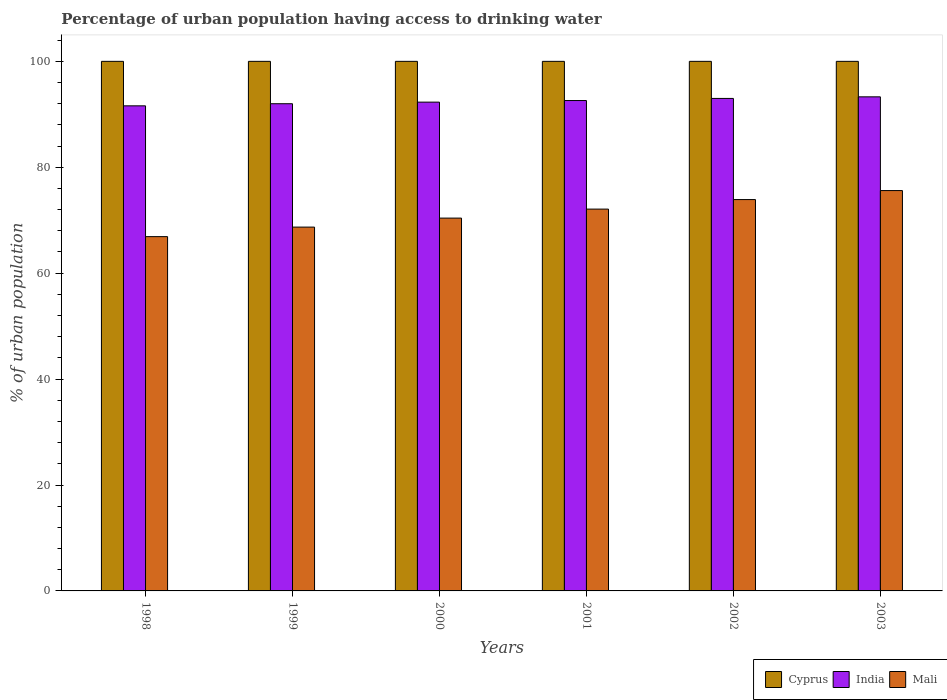How many groups of bars are there?
Provide a short and direct response. 6. Are the number of bars per tick equal to the number of legend labels?
Your response must be concise. Yes. What is the label of the 3rd group of bars from the left?
Your answer should be compact. 2000. In how many cases, is the number of bars for a given year not equal to the number of legend labels?
Provide a short and direct response. 0. What is the percentage of urban population having access to drinking water in Mali in 1999?
Provide a succinct answer. 68.7. Across all years, what is the maximum percentage of urban population having access to drinking water in India?
Offer a very short reply. 93.3. Across all years, what is the minimum percentage of urban population having access to drinking water in Mali?
Provide a succinct answer. 66.9. What is the total percentage of urban population having access to drinking water in Cyprus in the graph?
Ensure brevity in your answer.  600. What is the difference between the percentage of urban population having access to drinking water in India in 2000 and that in 2001?
Give a very brief answer. -0.3. What is the difference between the percentage of urban population having access to drinking water in Mali in 2002 and the percentage of urban population having access to drinking water in India in 1999?
Your response must be concise. -18.1. What is the average percentage of urban population having access to drinking water in Cyprus per year?
Provide a short and direct response. 100. In the year 1998, what is the difference between the percentage of urban population having access to drinking water in Mali and percentage of urban population having access to drinking water in Cyprus?
Provide a short and direct response. -33.1. In how many years, is the percentage of urban population having access to drinking water in India greater than 80 %?
Your answer should be compact. 6. What is the ratio of the percentage of urban population having access to drinking water in Mali in 1998 to that in 2000?
Offer a terse response. 0.95. Is the percentage of urban population having access to drinking water in Mali in 2000 less than that in 2002?
Provide a succinct answer. Yes. What is the difference between the highest and the second highest percentage of urban population having access to drinking water in Cyprus?
Your answer should be very brief. 0. What is the difference between the highest and the lowest percentage of urban population having access to drinking water in India?
Provide a short and direct response. 1.7. What does the 1st bar from the left in 2003 represents?
Give a very brief answer. Cyprus. What does the 1st bar from the right in 2001 represents?
Offer a very short reply. Mali. Is it the case that in every year, the sum of the percentage of urban population having access to drinking water in India and percentage of urban population having access to drinking water in Mali is greater than the percentage of urban population having access to drinking water in Cyprus?
Ensure brevity in your answer.  Yes. How many bars are there?
Make the answer very short. 18. How many years are there in the graph?
Offer a very short reply. 6. Are the values on the major ticks of Y-axis written in scientific E-notation?
Your answer should be compact. No. What is the title of the graph?
Make the answer very short. Percentage of urban population having access to drinking water. What is the label or title of the X-axis?
Provide a short and direct response. Years. What is the label or title of the Y-axis?
Your answer should be very brief. % of urban population. What is the % of urban population of Cyprus in 1998?
Make the answer very short. 100. What is the % of urban population in India in 1998?
Your answer should be very brief. 91.6. What is the % of urban population of Mali in 1998?
Make the answer very short. 66.9. What is the % of urban population of India in 1999?
Provide a short and direct response. 92. What is the % of urban population in Mali in 1999?
Keep it short and to the point. 68.7. What is the % of urban population of India in 2000?
Your answer should be compact. 92.3. What is the % of urban population in Mali in 2000?
Provide a short and direct response. 70.4. What is the % of urban population in Cyprus in 2001?
Your answer should be very brief. 100. What is the % of urban population in India in 2001?
Give a very brief answer. 92.6. What is the % of urban population of Mali in 2001?
Your answer should be very brief. 72.1. What is the % of urban population in India in 2002?
Your answer should be compact. 93. What is the % of urban population in Mali in 2002?
Provide a short and direct response. 73.9. What is the % of urban population of India in 2003?
Provide a short and direct response. 93.3. What is the % of urban population in Mali in 2003?
Your response must be concise. 75.6. Across all years, what is the maximum % of urban population of Cyprus?
Give a very brief answer. 100. Across all years, what is the maximum % of urban population of India?
Make the answer very short. 93.3. Across all years, what is the maximum % of urban population of Mali?
Offer a very short reply. 75.6. Across all years, what is the minimum % of urban population in India?
Give a very brief answer. 91.6. Across all years, what is the minimum % of urban population of Mali?
Make the answer very short. 66.9. What is the total % of urban population in Cyprus in the graph?
Your response must be concise. 600. What is the total % of urban population of India in the graph?
Your response must be concise. 554.8. What is the total % of urban population of Mali in the graph?
Your response must be concise. 427.6. What is the difference between the % of urban population of Cyprus in 1998 and that in 1999?
Provide a short and direct response. 0. What is the difference between the % of urban population of Mali in 1998 and that in 1999?
Your response must be concise. -1.8. What is the difference between the % of urban population of Cyprus in 1998 and that in 2000?
Your response must be concise. 0. What is the difference between the % of urban population of India in 1998 and that in 2000?
Your answer should be very brief. -0.7. What is the difference between the % of urban population of Mali in 1998 and that in 2000?
Your answer should be very brief. -3.5. What is the difference between the % of urban population in Cyprus in 1998 and that in 2002?
Ensure brevity in your answer.  0. What is the difference between the % of urban population of Mali in 1999 and that in 2000?
Keep it short and to the point. -1.7. What is the difference between the % of urban population of Cyprus in 1999 and that in 2001?
Ensure brevity in your answer.  0. What is the difference between the % of urban population of India in 1999 and that in 2001?
Give a very brief answer. -0.6. What is the difference between the % of urban population in India in 1999 and that in 2002?
Your response must be concise. -1. What is the difference between the % of urban population of Mali in 1999 and that in 2002?
Your answer should be compact. -5.2. What is the difference between the % of urban population of Mali in 2000 and that in 2001?
Offer a very short reply. -1.7. What is the difference between the % of urban population of Mali in 2000 and that in 2003?
Your answer should be very brief. -5.2. What is the difference between the % of urban population of Cyprus in 2001 and that in 2002?
Offer a very short reply. 0. What is the difference between the % of urban population in India in 2001 and that in 2002?
Provide a succinct answer. -0.4. What is the difference between the % of urban population in Cyprus in 2001 and that in 2003?
Offer a very short reply. 0. What is the difference between the % of urban population of India in 2001 and that in 2003?
Your response must be concise. -0.7. What is the difference between the % of urban population in Cyprus in 2002 and that in 2003?
Keep it short and to the point. 0. What is the difference between the % of urban population in India in 2002 and that in 2003?
Provide a succinct answer. -0.3. What is the difference between the % of urban population in Cyprus in 1998 and the % of urban population in Mali in 1999?
Your answer should be compact. 31.3. What is the difference between the % of urban population of India in 1998 and the % of urban population of Mali in 1999?
Give a very brief answer. 22.9. What is the difference between the % of urban population of Cyprus in 1998 and the % of urban population of Mali in 2000?
Provide a short and direct response. 29.6. What is the difference between the % of urban population in India in 1998 and the % of urban population in Mali in 2000?
Provide a short and direct response. 21.2. What is the difference between the % of urban population of Cyprus in 1998 and the % of urban population of Mali in 2001?
Your answer should be very brief. 27.9. What is the difference between the % of urban population in Cyprus in 1998 and the % of urban population in Mali in 2002?
Your answer should be compact. 26.1. What is the difference between the % of urban population in India in 1998 and the % of urban population in Mali in 2002?
Give a very brief answer. 17.7. What is the difference between the % of urban population of Cyprus in 1998 and the % of urban population of Mali in 2003?
Offer a very short reply. 24.4. What is the difference between the % of urban population in Cyprus in 1999 and the % of urban population in India in 2000?
Your answer should be compact. 7.7. What is the difference between the % of urban population of Cyprus in 1999 and the % of urban population of Mali in 2000?
Your answer should be very brief. 29.6. What is the difference between the % of urban population in India in 1999 and the % of urban population in Mali in 2000?
Offer a terse response. 21.6. What is the difference between the % of urban population in Cyprus in 1999 and the % of urban population in India in 2001?
Ensure brevity in your answer.  7.4. What is the difference between the % of urban population of Cyprus in 1999 and the % of urban population of Mali in 2001?
Provide a short and direct response. 27.9. What is the difference between the % of urban population in India in 1999 and the % of urban population in Mali in 2001?
Keep it short and to the point. 19.9. What is the difference between the % of urban population in Cyprus in 1999 and the % of urban population in Mali in 2002?
Your response must be concise. 26.1. What is the difference between the % of urban population in Cyprus in 1999 and the % of urban population in Mali in 2003?
Your answer should be very brief. 24.4. What is the difference between the % of urban population in India in 1999 and the % of urban population in Mali in 2003?
Your answer should be compact. 16.4. What is the difference between the % of urban population of Cyprus in 2000 and the % of urban population of Mali in 2001?
Keep it short and to the point. 27.9. What is the difference between the % of urban population of India in 2000 and the % of urban population of Mali in 2001?
Your response must be concise. 20.2. What is the difference between the % of urban population in Cyprus in 2000 and the % of urban population in Mali in 2002?
Your response must be concise. 26.1. What is the difference between the % of urban population in Cyprus in 2000 and the % of urban population in Mali in 2003?
Provide a short and direct response. 24.4. What is the difference between the % of urban population of Cyprus in 2001 and the % of urban population of India in 2002?
Keep it short and to the point. 7. What is the difference between the % of urban population in Cyprus in 2001 and the % of urban population in Mali in 2002?
Your answer should be compact. 26.1. What is the difference between the % of urban population of Cyprus in 2001 and the % of urban population of India in 2003?
Keep it short and to the point. 6.7. What is the difference between the % of urban population of Cyprus in 2001 and the % of urban population of Mali in 2003?
Offer a very short reply. 24.4. What is the difference between the % of urban population of Cyprus in 2002 and the % of urban population of Mali in 2003?
Keep it short and to the point. 24.4. What is the average % of urban population in Cyprus per year?
Make the answer very short. 100. What is the average % of urban population in India per year?
Provide a short and direct response. 92.47. What is the average % of urban population of Mali per year?
Your answer should be compact. 71.27. In the year 1998, what is the difference between the % of urban population of Cyprus and % of urban population of Mali?
Keep it short and to the point. 33.1. In the year 1998, what is the difference between the % of urban population of India and % of urban population of Mali?
Give a very brief answer. 24.7. In the year 1999, what is the difference between the % of urban population of Cyprus and % of urban population of India?
Provide a short and direct response. 8. In the year 1999, what is the difference between the % of urban population in Cyprus and % of urban population in Mali?
Offer a very short reply. 31.3. In the year 1999, what is the difference between the % of urban population of India and % of urban population of Mali?
Make the answer very short. 23.3. In the year 2000, what is the difference between the % of urban population in Cyprus and % of urban population in India?
Your answer should be very brief. 7.7. In the year 2000, what is the difference between the % of urban population of Cyprus and % of urban population of Mali?
Offer a terse response. 29.6. In the year 2000, what is the difference between the % of urban population of India and % of urban population of Mali?
Offer a terse response. 21.9. In the year 2001, what is the difference between the % of urban population of Cyprus and % of urban population of Mali?
Offer a terse response. 27.9. In the year 2002, what is the difference between the % of urban population of Cyprus and % of urban population of India?
Your response must be concise. 7. In the year 2002, what is the difference between the % of urban population in Cyprus and % of urban population in Mali?
Offer a terse response. 26.1. In the year 2003, what is the difference between the % of urban population in Cyprus and % of urban population in India?
Keep it short and to the point. 6.7. In the year 2003, what is the difference between the % of urban population in Cyprus and % of urban population in Mali?
Provide a short and direct response. 24.4. What is the ratio of the % of urban population of Cyprus in 1998 to that in 1999?
Give a very brief answer. 1. What is the ratio of the % of urban population in Mali in 1998 to that in 1999?
Give a very brief answer. 0.97. What is the ratio of the % of urban population of Mali in 1998 to that in 2000?
Keep it short and to the point. 0.95. What is the ratio of the % of urban population in India in 1998 to that in 2001?
Your answer should be very brief. 0.99. What is the ratio of the % of urban population in Mali in 1998 to that in 2001?
Offer a very short reply. 0.93. What is the ratio of the % of urban population in India in 1998 to that in 2002?
Provide a short and direct response. 0.98. What is the ratio of the % of urban population of Mali in 1998 to that in 2002?
Offer a very short reply. 0.91. What is the ratio of the % of urban population of Cyprus in 1998 to that in 2003?
Your response must be concise. 1. What is the ratio of the % of urban population in India in 1998 to that in 2003?
Make the answer very short. 0.98. What is the ratio of the % of urban population in Mali in 1998 to that in 2003?
Make the answer very short. 0.88. What is the ratio of the % of urban population in Mali in 1999 to that in 2000?
Offer a very short reply. 0.98. What is the ratio of the % of urban population in Mali in 1999 to that in 2001?
Keep it short and to the point. 0.95. What is the ratio of the % of urban population of Mali in 1999 to that in 2002?
Keep it short and to the point. 0.93. What is the ratio of the % of urban population in India in 1999 to that in 2003?
Your answer should be compact. 0.99. What is the ratio of the % of urban population of Mali in 1999 to that in 2003?
Provide a succinct answer. 0.91. What is the ratio of the % of urban population in India in 2000 to that in 2001?
Provide a short and direct response. 1. What is the ratio of the % of urban population of Mali in 2000 to that in 2001?
Your answer should be very brief. 0.98. What is the ratio of the % of urban population of Mali in 2000 to that in 2002?
Ensure brevity in your answer.  0.95. What is the ratio of the % of urban population in India in 2000 to that in 2003?
Make the answer very short. 0.99. What is the ratio of the % of urban population of Mali in 2000 to that in 2003?
Provide a succinct answer. 0.93. What is the ratio of the % of urban population in India in 2001 to that in 2002?
Offer a terse response. 1. What is the ratio of the % of urban population of Mali in 2001 to that in 2002?
Keep it short and to the point. 0.98. What is the ratio of the % of urban population of Cyprus in 2001 to that in 2003?
Provide a short and direct response. 1. What is the ratio of the % of urban population of Mali in 2001 to that in 2003?
Ensure brevity in your answer.  0.95. What is the ratio of the % of urban population of India in 2002 to that in 2003?
Provide a succinct answer. 1. What is the ratio of the % of urban population in Mali in 2002 to that in 2003?
Make the answer very short. 0.98. What is the difference between the highest and the second highest % of urban population in Cyprus?
Provide a succinct answer. 0. What is the difference between the highest and the second highest % of urban population in India?
Provide a short and direct response. 0.3. What is the difference between the highest and the lowest % of urban population in Cyprus?
Your response must be concise. 0. What is the difference between the highest and the lowest % of urban population of Mali?
Keep it short and to the point. 8.7. 